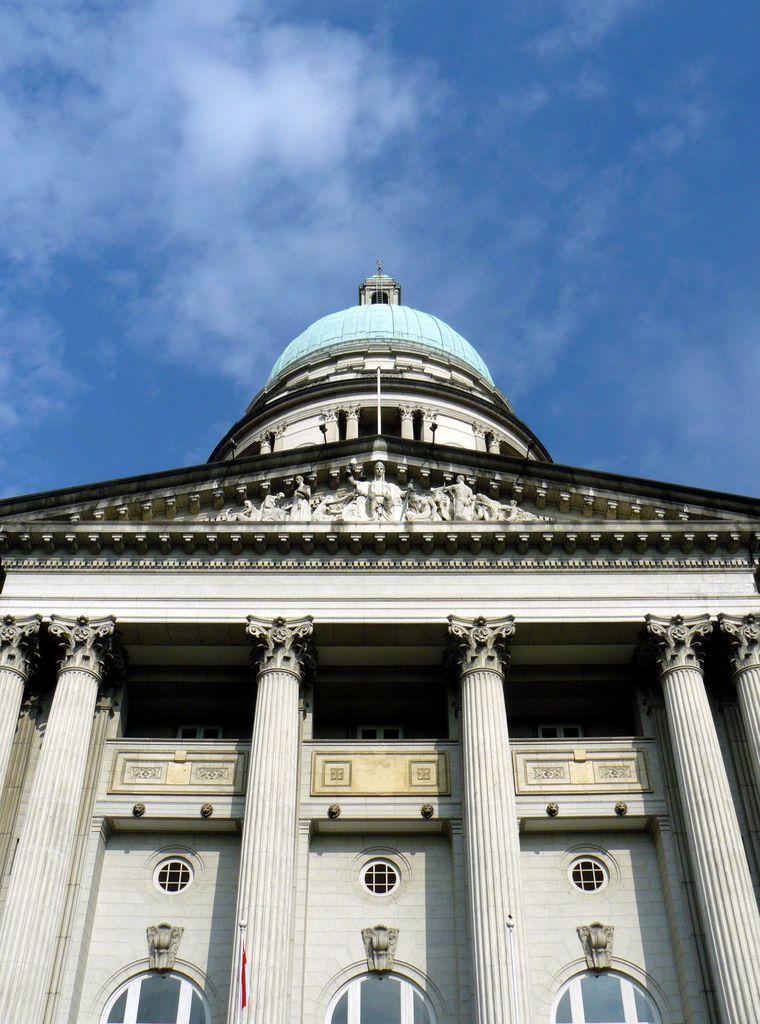Please provide a concise description of this image. In this image I can see a white colour building, number of pillars and on the top side of the building I can see few sculptures. In the background I can see clouds and the sky. 